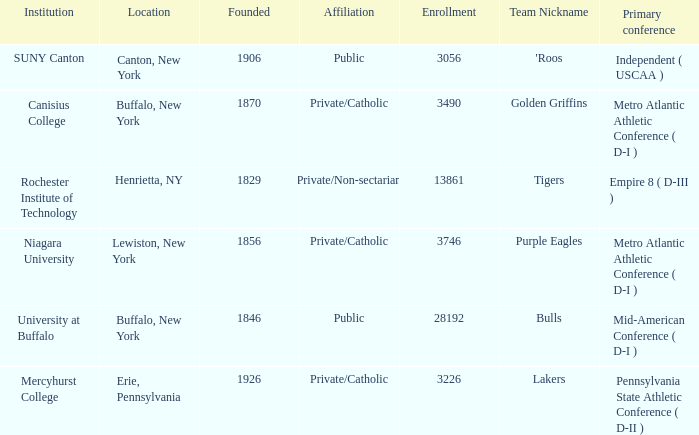What kind of school is Canton, New York? Public. 